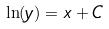Convert formula to latex. <formula><loc_0><loc_0><loc_500><loc_500>\ln ( y ) = x + C</formula> 